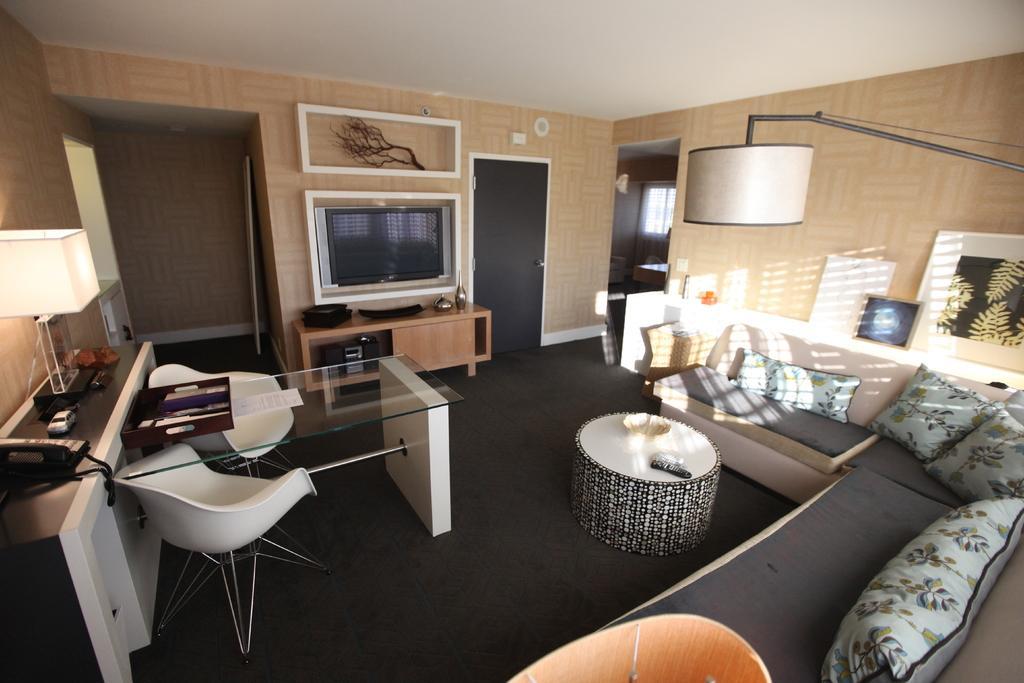Could you give a brief overview of what you see in this image? In this image I can see a couch and the table. To the left there is a lamp and some objects on the table. In the back there is a television and the frames attached to the wall. 